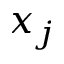<formula> <loc_0><loc_0><loc_500><loc_500>x _ { j }</formula> 